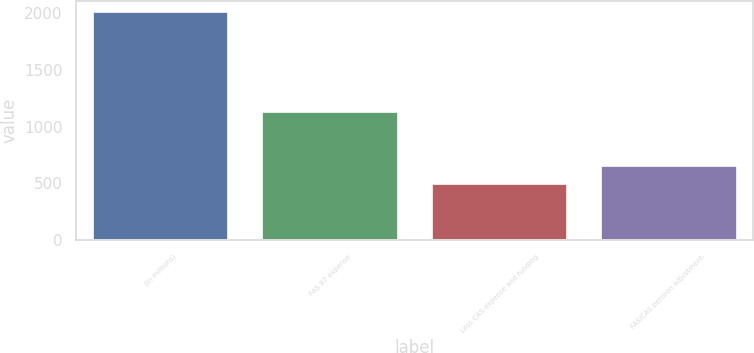Convert chart to OTSL. <chart><loc_0><loc_0><loc_500><loc_500><bar_chart><fcel>(In millions)<fcel>FAS 87 expense<fcel>Less CAS expense and funding<fcel>FAS/CAS pension adjustment-<nl><fcel>2005<fcel>1124<fcel>498<fcel>648.7<nl></chart> 